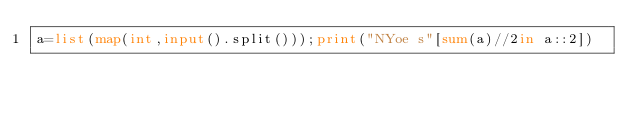<code> <loc_0><loc_0><loc_500><loc_500><_Python_>a=list(map(int,input().split()));print("NYoe s"[sum(a)//2in a::2])</code> 